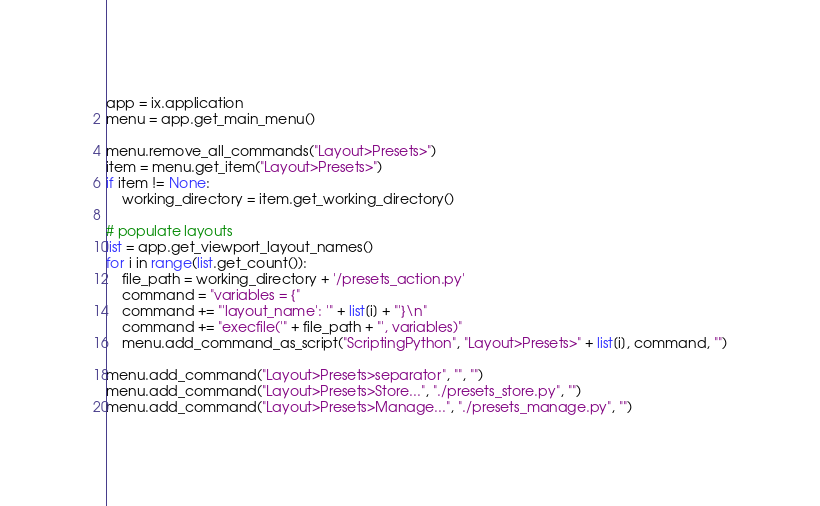Convert code to text. <code><loc_0><loc_0><loc_500><loc_500><_Python_>app = ix.application
menu = app.get_main_menu()

menu.remove_all_commands("Layout>Presets>")
item = menu.get_item("Layout>Presets>")
if item != None:
	working_directory = item.get_working_directory()

# populate layouts
list = app.get_viewport_layout_names()
for i in range(list.get_count()):
    file_path = working_directory + '/presets_action.py'
    command = "variables = {"
    command += "'layout_name': '" + list[i] + "'}\n"
    command += "execfile('" + file_path + "', variables)"
    menu.add_command_as_script("ScriptingPython", "Layout>Presets>" + list[i], command, "")

menu.add_command("Layout>Presets>separator", "", "")
menu.add_command("Layout>Presets>Store...", "./presets_store.py", "")
menu.add_command("Layout>Presets>Manage...", "./presets_manage.py", "")</code> 